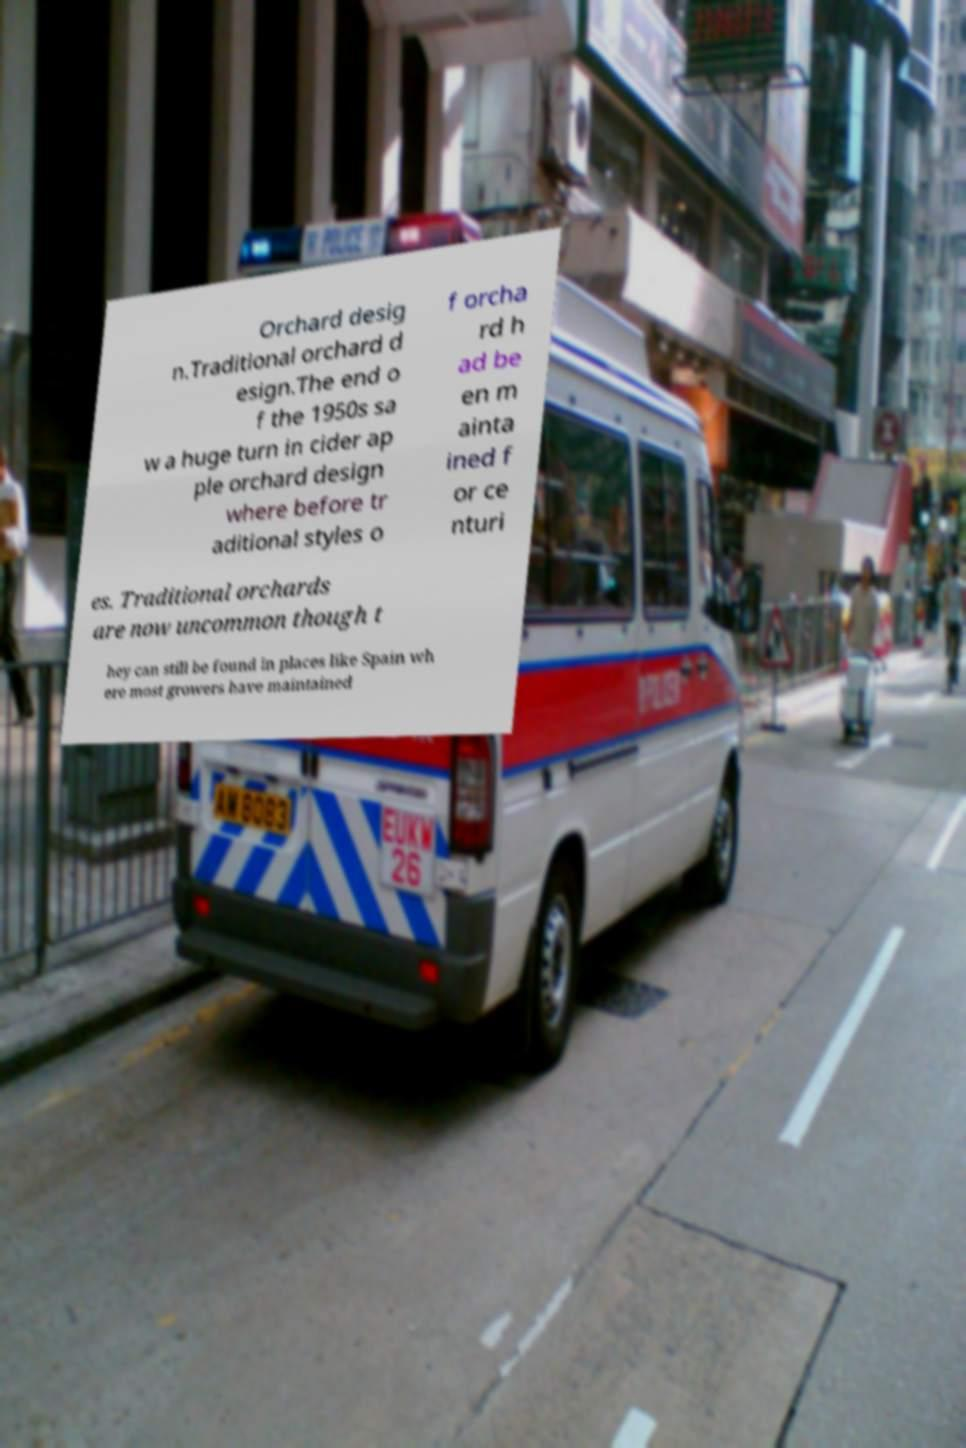Can you read and provide the text displayed in the image?This photo seems to have some interesting text. Can you extract and type it out for me? Orchard desig n.Traditional orchard d esign.The end o f the 1950s sa w a huge turn in cider ap ple orchard design where before tr aditional styles o f orcha rd h ad be en m ainta ined f or ce nturi es. Traditional orchards are now uncommon though t hey can still be found in places like Spain wh ere most growers have maintained 